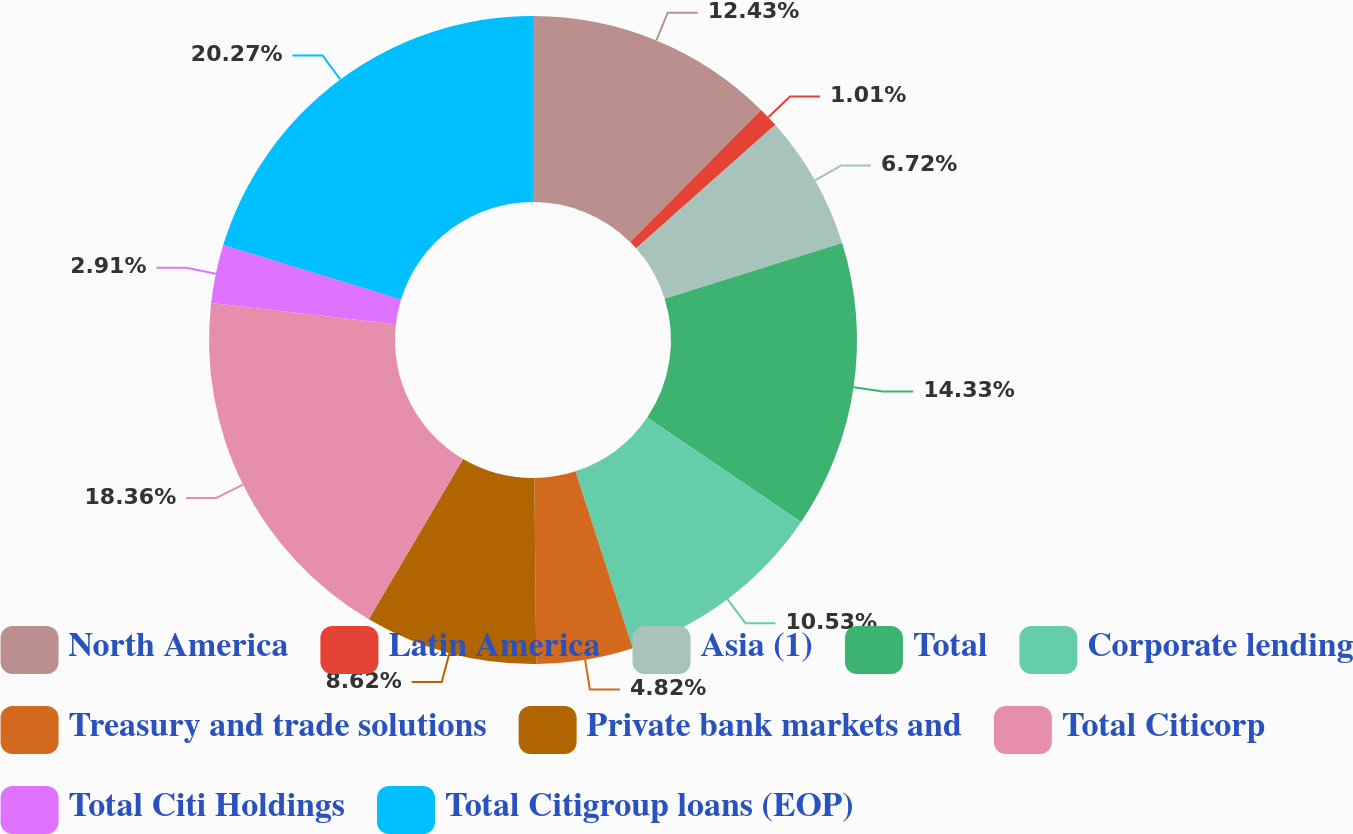Convert chart. <chart><loc_0><loc_0><loc_500><loc_500><pie_chart><fcel>North America<fcel>Latin America<fcel>Asia (1)<fcel>Total<fcel>Corporate lending<fcel>Treasury and trade solutions<fcel>Private bank markets and<fcel>Total Citicorp<fcel>Total Citi Holdings<fcel>Total Citigroup loans (EOP)<nl><fcel>12.43%<fcel>1.01%<fcel>6.72%<fcel>14.33%<fcel>10.53%<fcel>4.82%<fcel>8.62%<fcel>18.36%<fcel>2.91%<fcel>20.27%<nl></chart> 